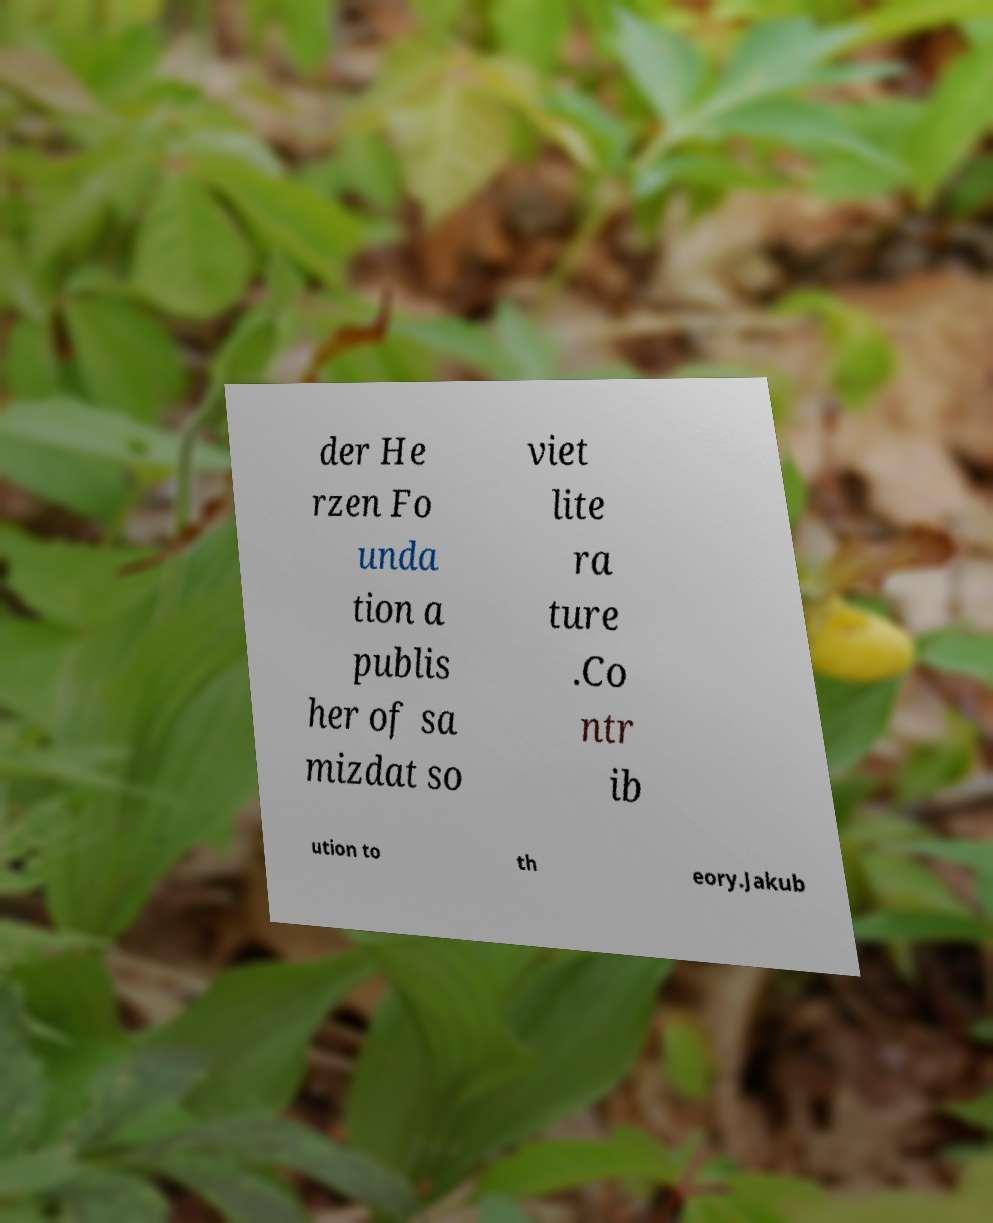For documentation purposes, I need the text within this image transcribed. Could you provide that? der He rzen Fo unda tion a publis her of sa mizdat so viet lite ra ture .Co ntr ib ution to th eory.Jakub 